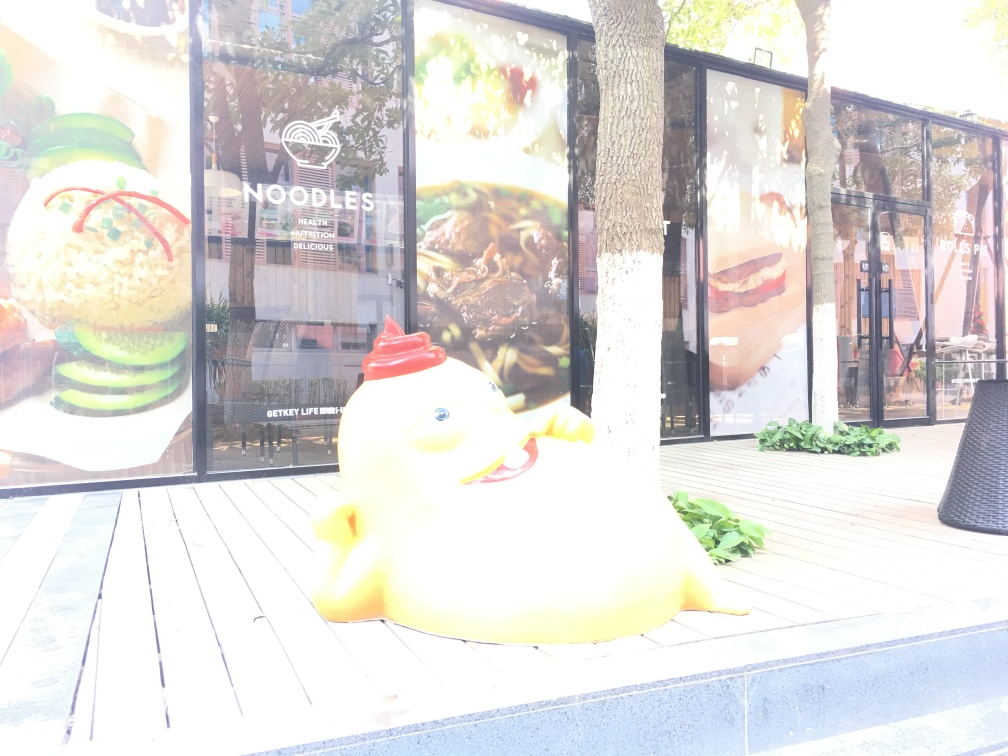What is the main subject in this image? The main subject in this image appears to be a whimsical, oversized model of a chick in a playful pose, which may be a form of street art or advertising material situated on a wooden deck. Can you tell me more about the location or setting? The setting includes outdoor seating typical of a cafe or restaurant. In the background is a large window displaying images of food and the word 'NOODLES,' suggesting that the location may be near an eatery that serves noodle dishes. The presence of trees and greenery indicates an urban location that incorporates natural elements for a more inviting atmosphere. Is there any cultural significance to the subject or context? While the image doesn't provide explicit cultural context, the playful chick figure could be associated with themes of youthfulness, new beginnings, or food-related marketing, given its proximity to what seems to be a food establishment. The exact cultural significance would depend on the local context and how such an installation is perceived by the community or visitors. 